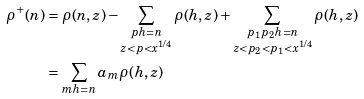Convert formula to latex. <formula><loc_0><loc_0><loc_500><loc_500>\rho ^ { + } ( n ) & = \rho ( n , z ) - \sum _ { \substack { p h = n \\ z < p < x ^ { 1 / 4 } } } \rho ( h , z ) + \sum _ { \substack { p _ { 1 } p _ { 2 } h = n \\ z < p _ { 2 } < p _ { 1 } < x ^ { 1 / 4 } } } \rho ( h , z ) \\ & = \sum _ { m h = n } a _ { m } \rho ( h , z )</formula> 